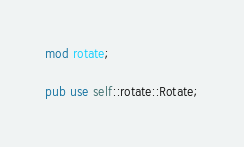Convert code to text. <code><loc_0><loc_0><loc_500><loc_500><_Rust_>mod rotate;

pub use self::rotate::Rotate;
</code> 